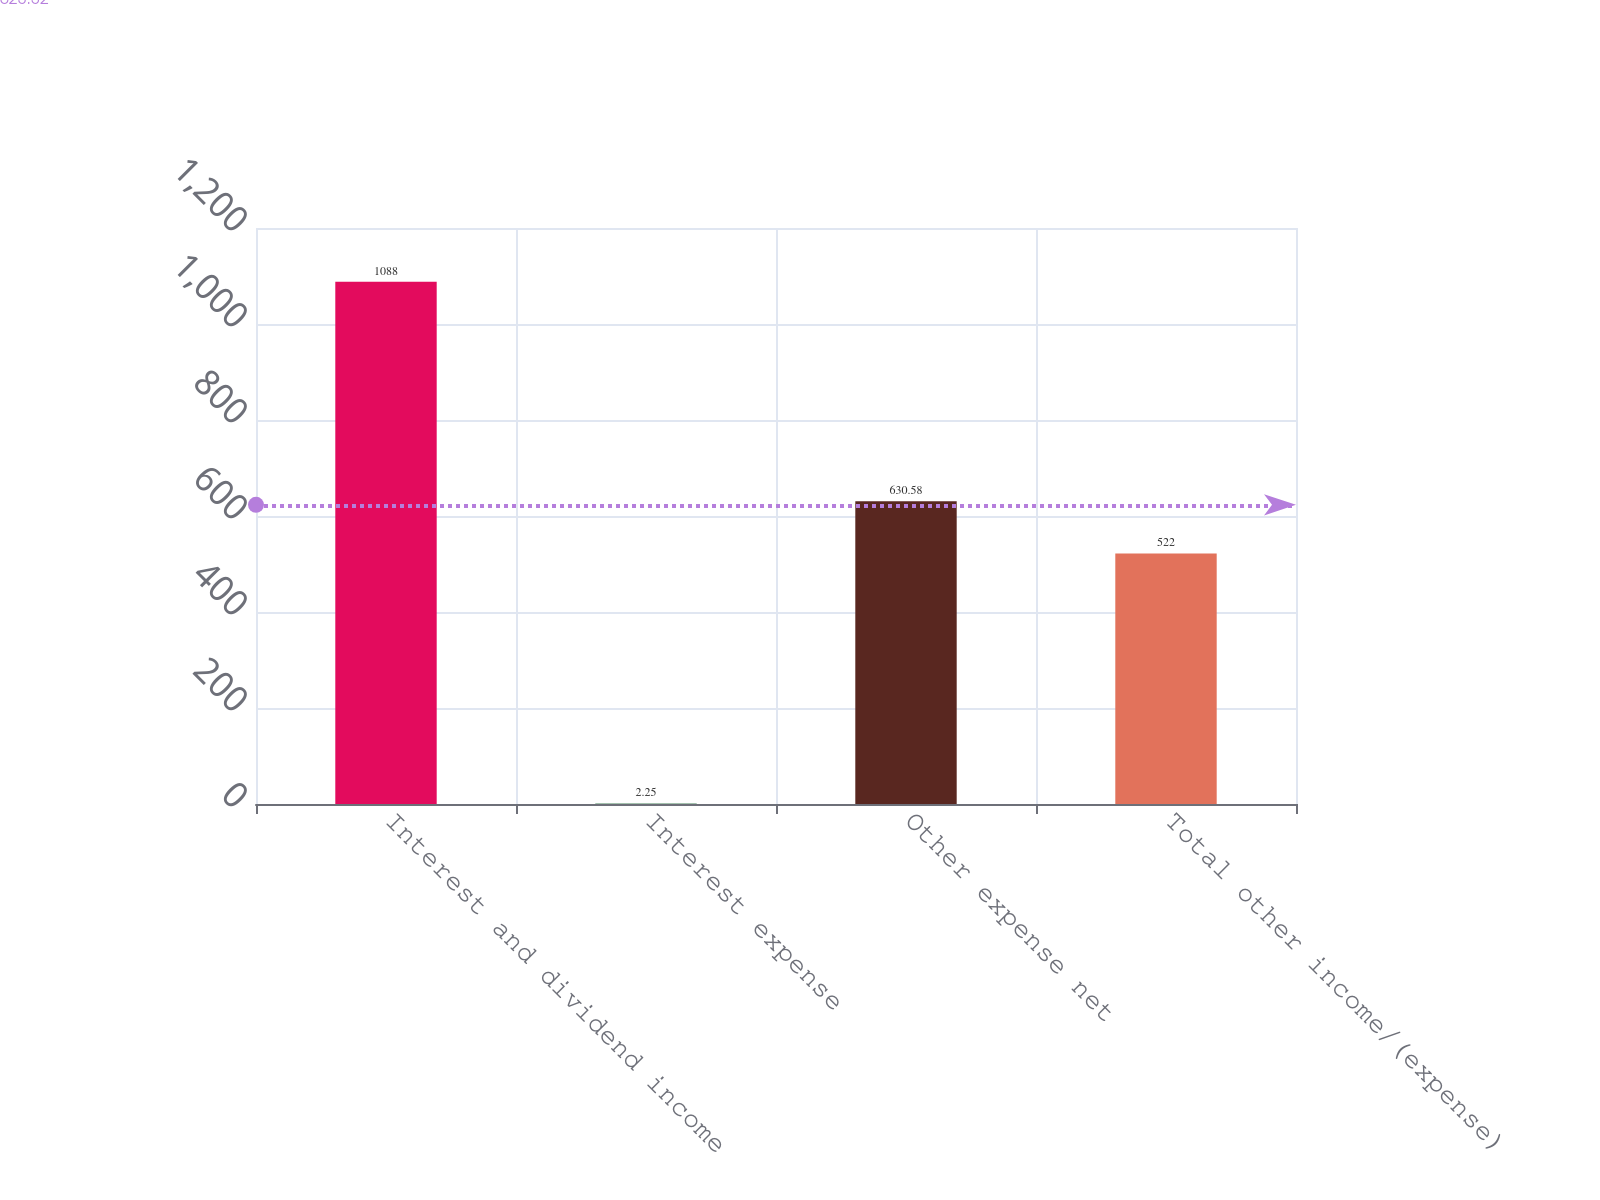Convert chart. <chart><loc_0><loc_0><loc_500><loc_500><bar_chart><fcel>Interest and dividend income<fcel>Interest expense<fcel>Other expense net<fcel>Total other income/(expense)<nl><fcel>1088<fcel>2.25<fcel>630.58<fcel>522<nl></chart> 